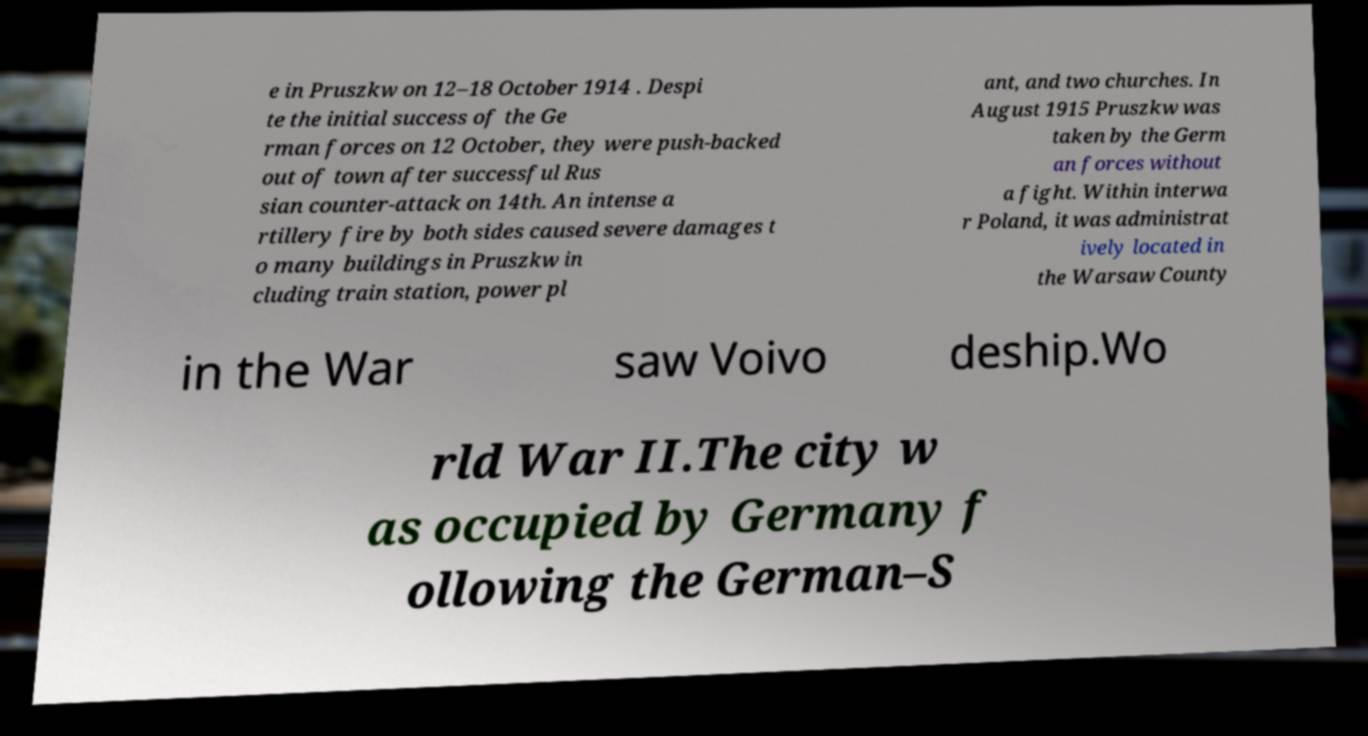What messages or text are displayed in this image? I need them in a readable, typed format. e in Pruszkw on 12–18 October 1914 . Despi te the initial success of the Ge rman forces on 12 October, they were push-backed out of town after successful Rus sian counter-attack on 14th. An intense a rtillery fire by both sides caused severe damages t o many buildings in Pruszkw in cluding train station, power pl ant, and two churches. In August 1915 Pruszkw was taken by the Germ an forces without a fight. Within interwa r Poland, it was administrat ively located in the Warsaw County in the War saw Voivo deship.Wo rld War II.The city w as occupied by Germany f ollowing the German–S 